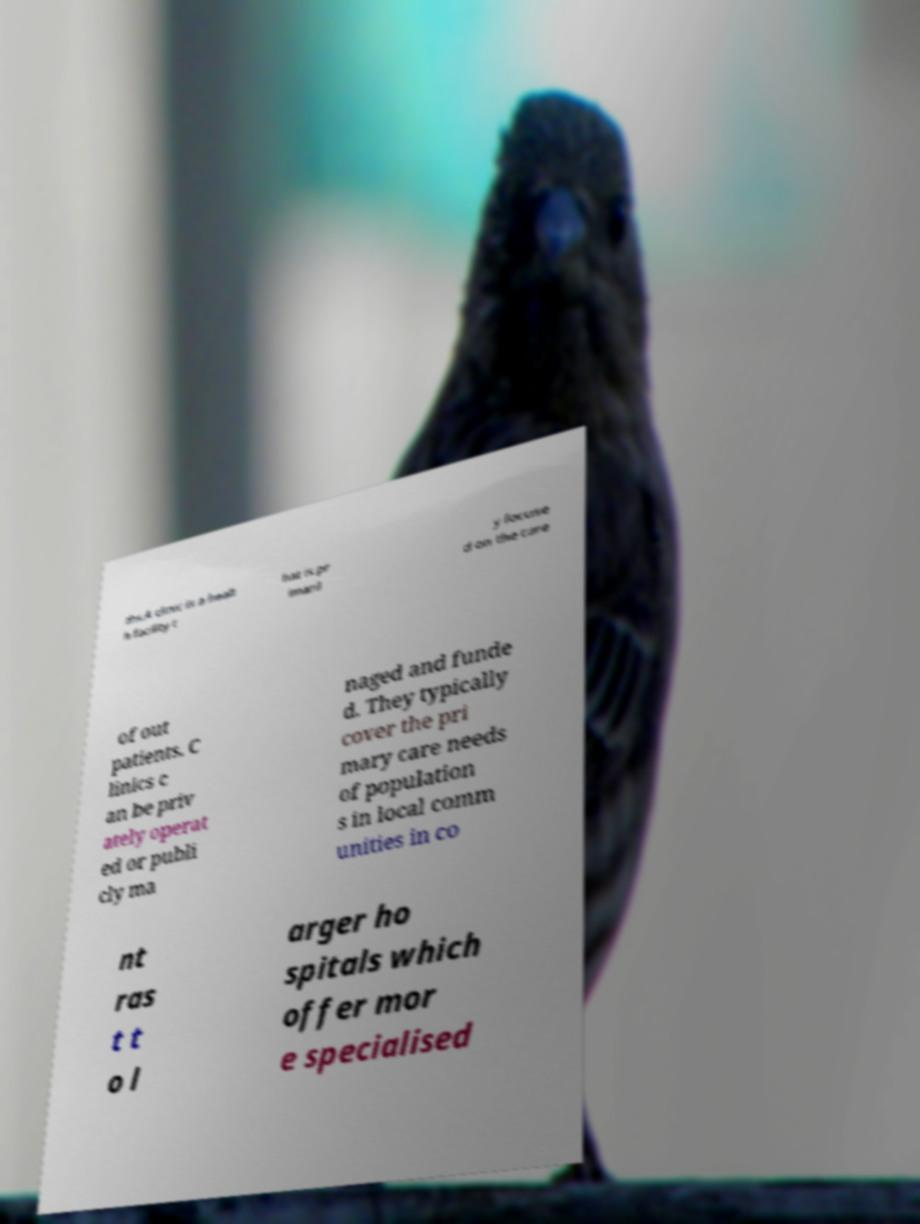Could you assist in decoding the text presented in this image and type it out clearly? ths.A clinic is a healt h facility t hat is pr imaril y focuse d on the care of out patients. C linics c an be priv ately operat ed or publi cly ma naged and funde d. They typically cover the pri mary care needs of population s in local comm unities in co nt ras t t o l arger ho spitals which offer mor e specialised 